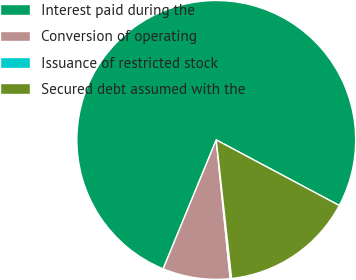Convert chart to OTSL. <chart><loc_0><loc_0><loc_500><loc_500><pie_chart><fcel>Interest paid during the<fcel>Conversion of operating<fcel>Issuance of restricted stock<fcel>Secured debt assumed with the<nl><fcel>76.58%<fcel>7.81%<fcel>0.17%<fcel>15.45%<nl></chart> 